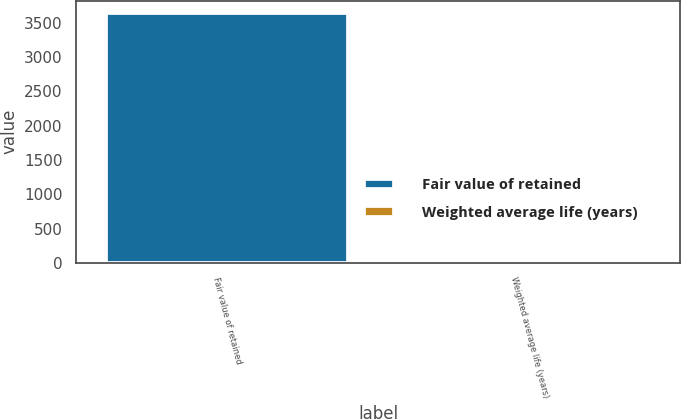<chart> <loc_0><loc_0><loc_500><loc_500><bar_chart><fcel>Fair value of retained<fcel>Weighted average life (years)<nl><fcel>3641<fcel>8.3<nl></chart> 